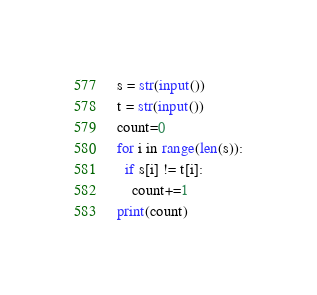Convert code to text. <code><loc_0><loc_0><loc_500><loc_500><_Python_>s = str(input())
t = str(input())
count=0
for i in range(len(s)):
  if s[i] != t[i]:
    count+=1
print(count)</code> 